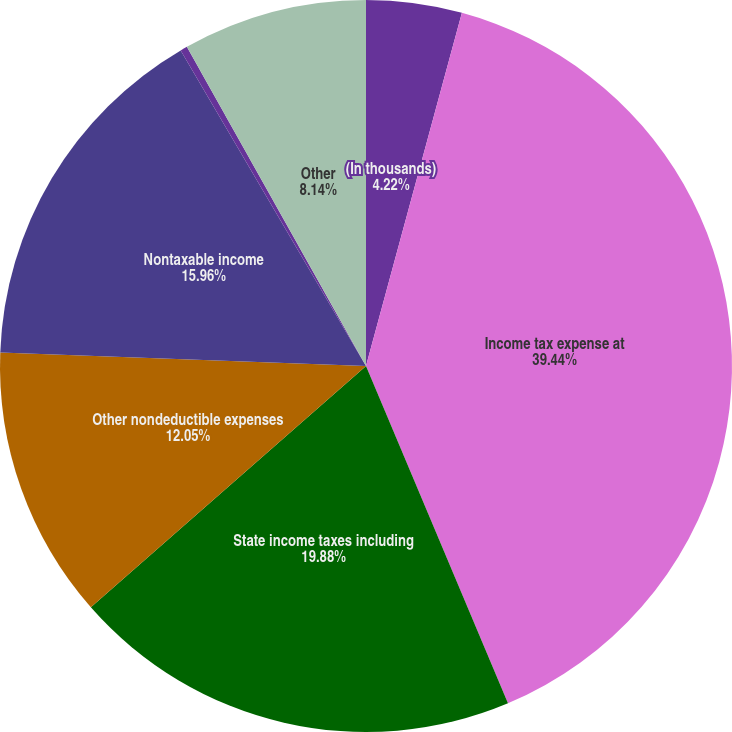<chart> <loc_0><loc_0><loc_500><loc_500><pie_chart><fcel>(In thousands)<fcel>Income tax expense at<fcel>State income taxes including<fcel>Other nondeductible expenses<fcel>Nontaxable income<fcel>Tax credits and other taxes<fcel>Other<nl><fcel>4.22%<fcel>39.44%<fcel>19.88%<fcel>12.05%<fcel>15.96%<fcel>0.31%<fcel>8.14%<nl></chart> 